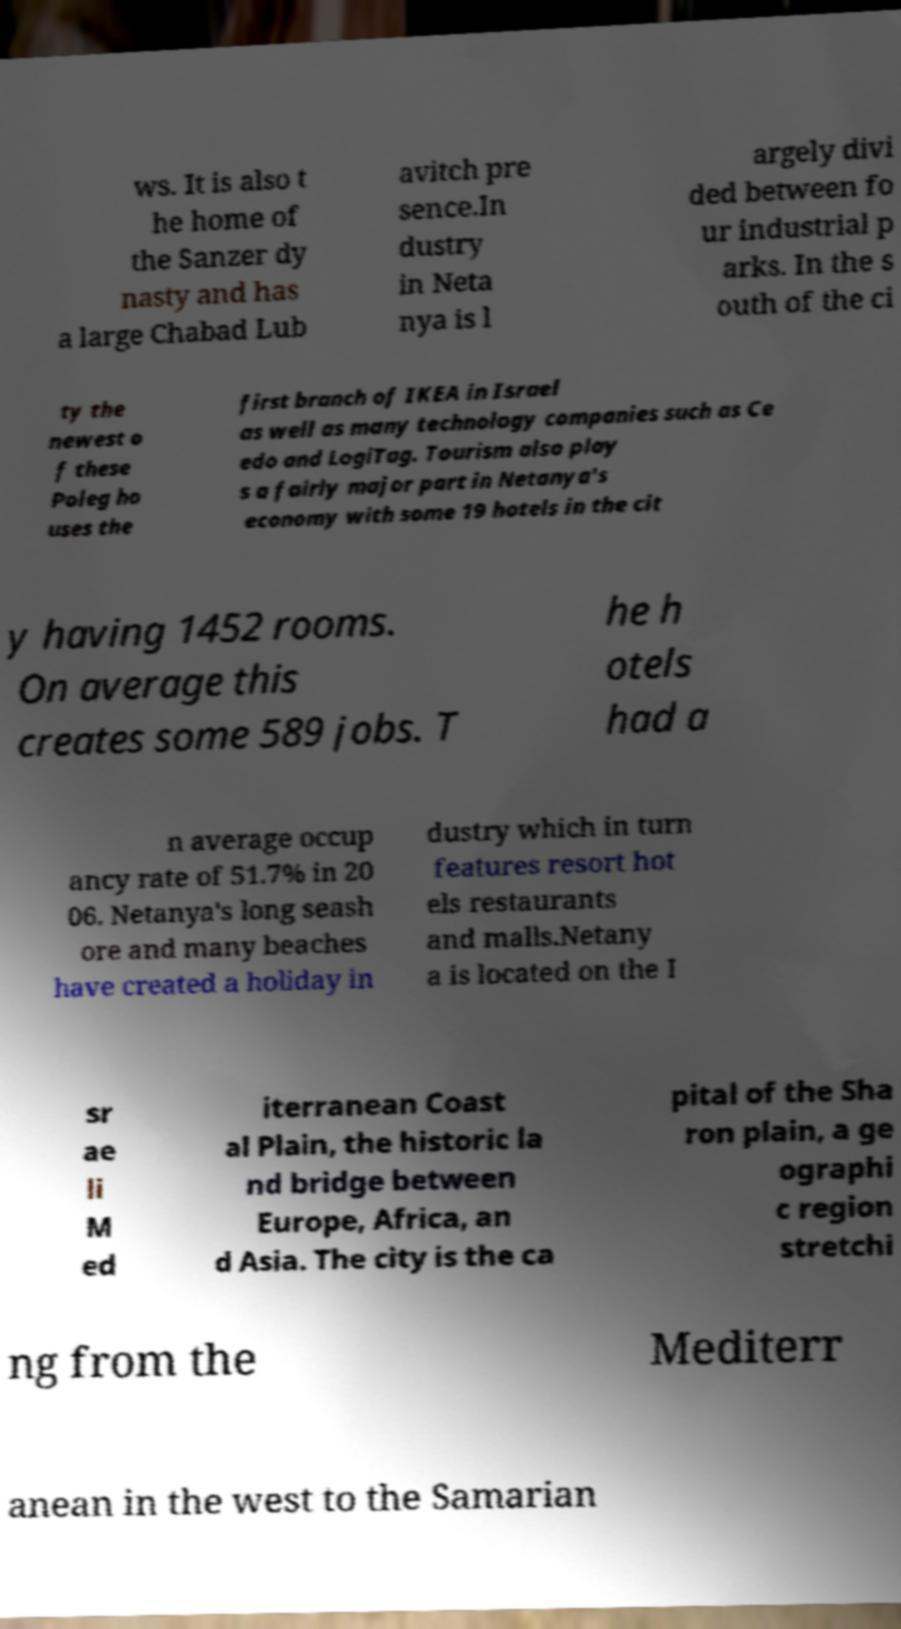There's text embedded in this image that I need extracted. Can you transcribe it verbatim? ws. It is also t he home of the Sanzer dy nasty and has a large Chabad Lub avitch pre sence.In dustry in Neta nya is l argely divi ded between fo ur industrial p arks. In the s outh of the ci ty the newest o f these Poleg ho uses the first branch of IKEA in Israel as well as many technology companies such as Ce edo and LogiTag. Tourism also play s a fairly major part in Netanya's economy with some 19 hotels in the cit y having 1452 rooms. On average this creates some 589 jobs. T he h otels had a n average occup ancy rate of 51.7% in 20 06. Netanya's long seash ore and many beaches have created a holiday in dustry which in turn features resort hot els restaurants and malls.Netany a is located on the I sr ae li M ed iterranean Coast al Plain, the historic la nd bridge between Europe, Africa, an d Asia. The city is the ca pital of the Sha ron plain, a ge ographi c region stretchi ng from the Mediterr anean in the west to the Samarian 